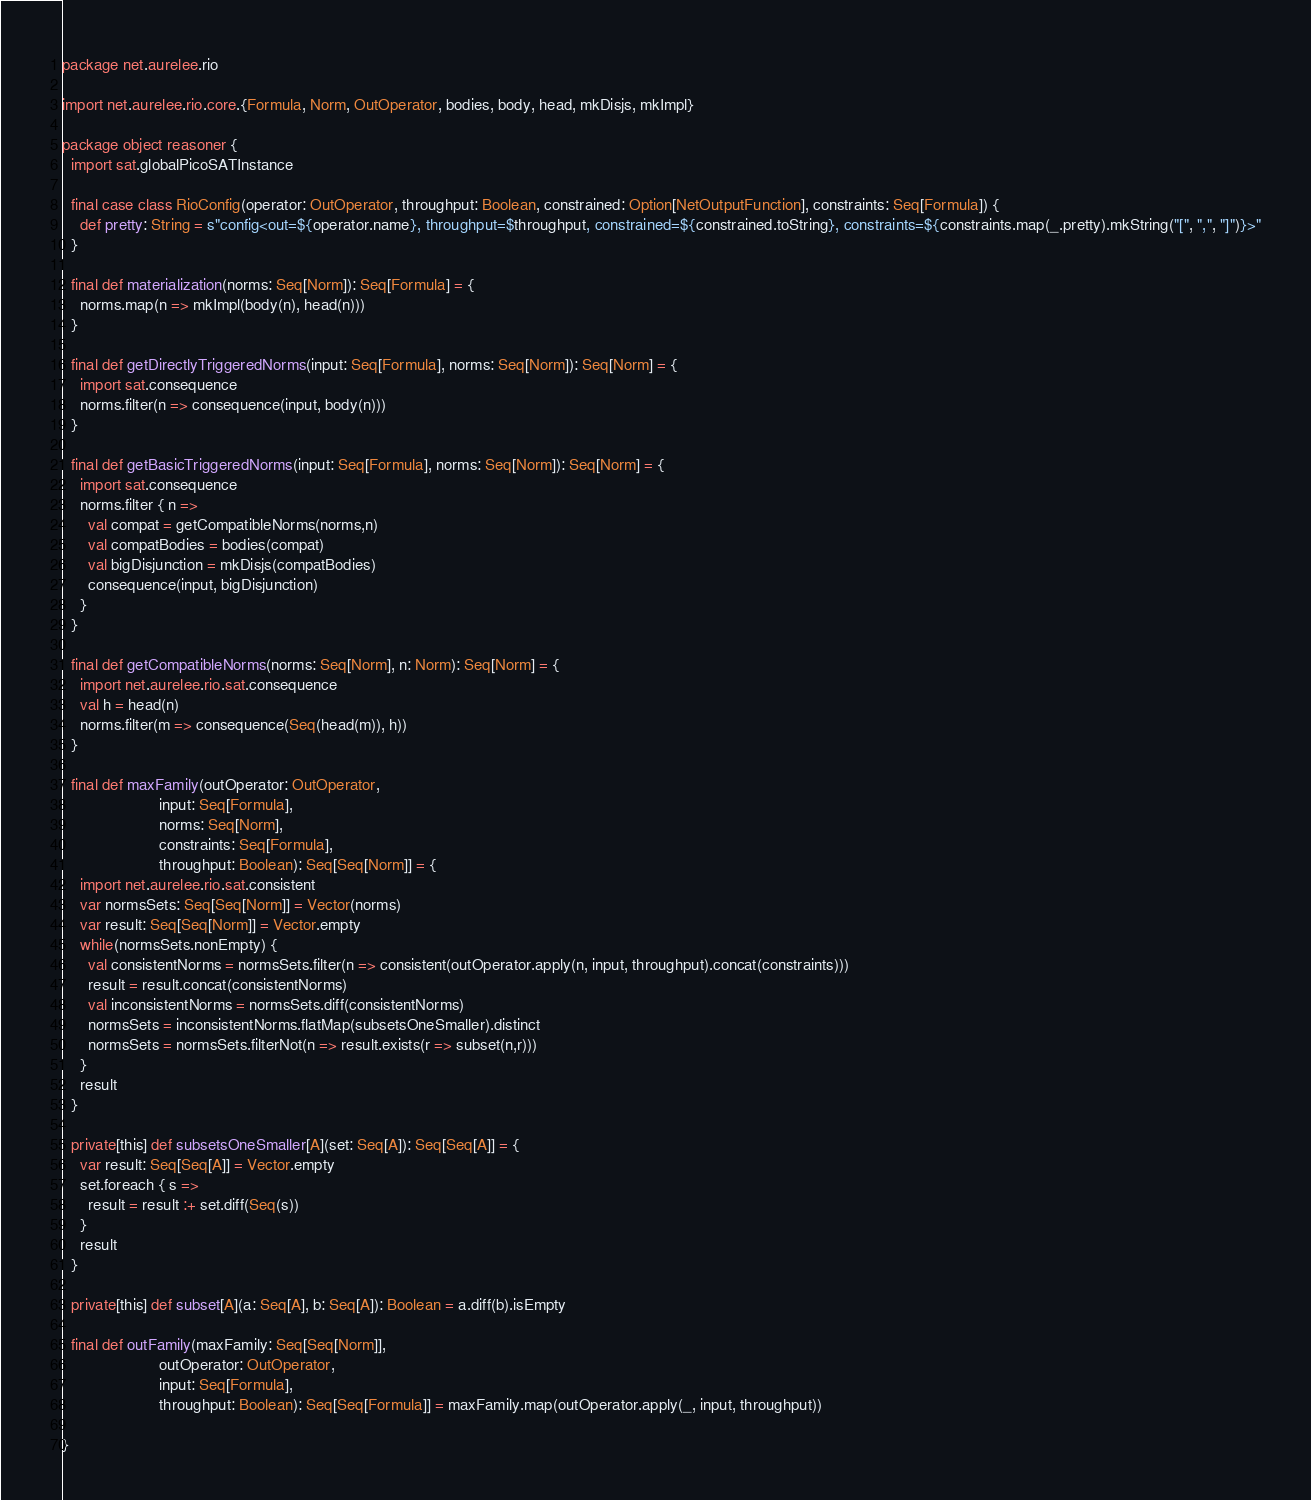Convert code to text. <code><loc_0><loc_0><loc_500><loc_500><_Scala_>package net.aurelee.rio

import net.aurelee.rio.core.{Formula, Norm, OutOperator, bodies, body, head, mkDisjs, mkImpl}

package object reasoner {
  import sat.globalPicoSATInstance

  final case class RioConfig(operator: OutOperator, throughput: Boolean, constrained: Option[NetOutputFunction], constraints: Seq[Formula]) {
    def pretty: String = s"config<out=${operator.name}, throughput=$throughput, constrained=${constrained.toString}, constraints=${constraints.map(_.pretty).mkString("[", ",", "]")}>"
  }

  final def materialization(norms: Seq[Norm]): Seq[Formula] = {
    norms.map(n => mkImpl(body(n), head(n)))
  }

  final def getDirectlyTriggeredNorms(input: Seq[Formula], norms: Seq[Norm]): Seq[Norm] = {
    import sat.consequence
    norms.filter(n => consequence(input, body(n)))
  }

  final def getBasicTriggeredNorms(input: Seq[Formula], norms: Seq[Norm]): Seq[Norm] = {
    import sat.consequence
    norms.filter { n =>
      val compat = getCompatibleNorms(norms,n)
      val compatBodies = bodies(compat)
      val bigDisjunction = mkDisjs(compatBodies)
      consequence(input, bigDisjunction)
    }
  }

  final def getCompatibleNorms(norms: Seq[Norm], n: Norm): Seq[Norm] = {
    import net.aurelee.rio.sat.consequence
    val h = head(n)
    norms.filter(m => consequence(Seq(head(m)), h))
  }

  final def maxFamily(outOperator: OutOperator,
                      input: Seq[Formula],
                      norms: Seq[Norm],
                      constraints: Seq[Formula],
                      throughput: Boolean): Seq[Seq[Norm]] = {
    import net.aurelee.rio.sat.consistent
    var normsSets: Seq[Seq[Norm]] = Vector(norms)
    var result: Seq[Seq[Norm]] = Vector.empty
    while(normsSets.nonEmpty) {
      val consistentNorms = normsSets.filter(n => consistent(outOperator.apply(n, input, throughput).concat(constraints)))
      result = result.concat(consistentNorms)
      val inconsistentNorms = normsSets.diff(consistentNorms)
      normsSets = inconsistentNorms.flatMap(subsetsOneSmaller).distinct
      normsSets = normsSets.filterNot(n => result.exists(r => subset(n,r)))
    }
    result
  }

  private[this] def subsetsOneSmaller[A](set: Seq[A]): Seq[Seq[A]] = {
    var result: Seq[Seq[A]] = Vector.empty
    set.foreach { s =>
      result = result :+ set.diff(Seq(s))
    }
    result
  }

  private[this] def subset[A](a: Seq[A], b: Seq[A]): Boolean = a.diff(b).isEmpty

  final def outFamily(maxFamily: Seq[Seq[Norm]],
                      outOperator: OutOperator,
                      input: Seq[Formula],
                      throughput: Boolean): Seq[Seq[Formula]] = maxFamily.map(outOperator.apply(_, input, throughput))

}
</code> 